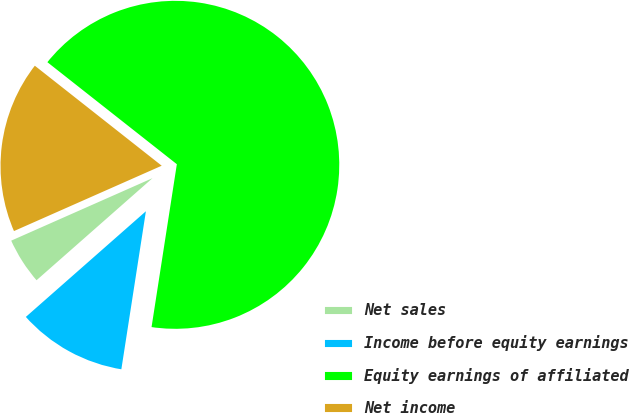<chart> <loc_0><loc_0><loc_500><loc_500><pie_chart><fcel>Net sales<fcel>Income before equity earnings<fcel>Equity earnings of affiliated<fcel>Net income<nl><fcel>4.86%<fcel>11.06%<fcel>66.83%<fcel>17.25%<nl></chart> 